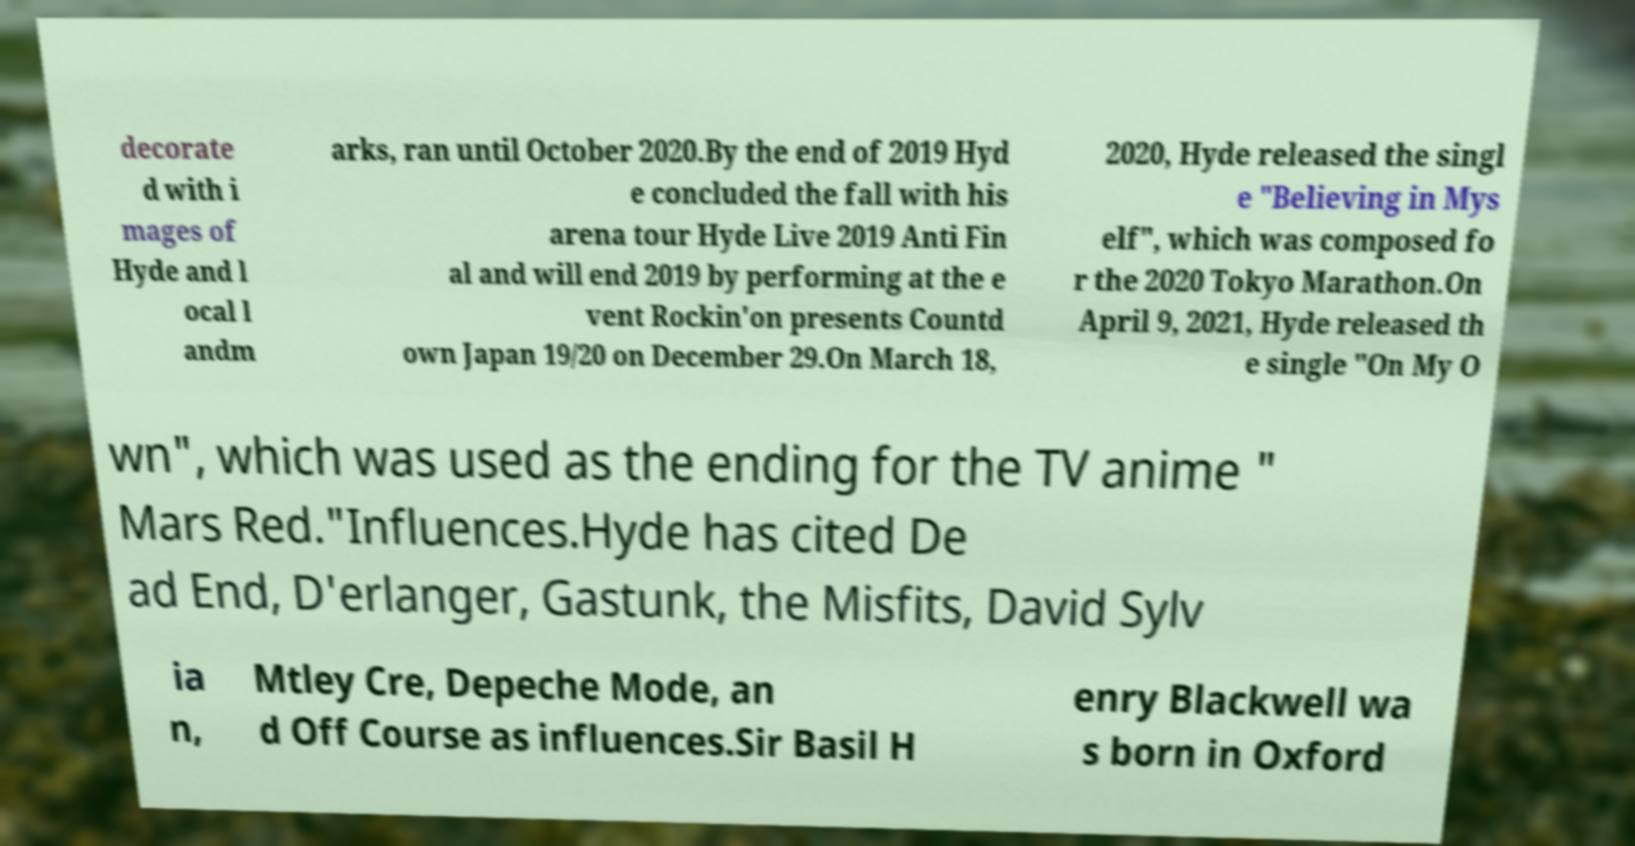I need the written content from this picture converted into text. Can you do that? decorate d with i mages of Hyde and l ocal l andm arks, ran until October 2020.By the end of 2019 Hyd e concluded the fall with his arena tour Hyde Live 2019 Anti Fin al and will end 2019 by performing at the e vent Rockin'on presents Countd own Japan 19/20 on December 29.On March 18, 2020, Hyde released the singl e "Believing in Mys elf", which was composed fo r the 2020 Tokyo Marathon.On April 9, 2021, Hyde released th e single "On My O wn", which was used as the ending for the TV anime " Mars Red."Influences.Hyde has cited De ad End, D'erlanger, Gastunk, the Misfits, David Sylv ia n, Mtley Cre, Depeche Mode, an d Off Course as influences.Sir Basil H enry Blackwell wa s born in Oxford 